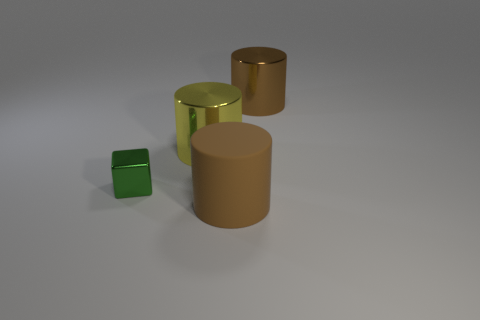What is the shape of the thing that is the same color as the rubber cylinder?
Your response must be concise. Cylinder. Is there a yellow metal thing that is in front of the brown cylinder in front of the green object?
Make the answer very short. No. What number of rubber spheres are the same size as the yellow metal cylinder?
Keep it short and to the point. 0. There is a metal cylinder that is left of the cylinder that is in front of the tiny green metallic cube; what number of big yellow cylinders are behind it?
Offer a very short reply. 0. How many cylinders are in front of the tiny cube and on the left side of the rubber cylinder?
Keep it short and to the point. 0. Is there any other thing that is the same color as the large matte cylinder?
Your answer should be very brief. Yes. How many metallic objects are either tiny cubes or yellow cylinders?
Provide a succinct answer. 2. The big brown object behind the brown cylinder that is to the left of the metal thing on the right side of the yellow object is made of what material?
Your response must be concise. Metal. What material is the brown thing that is left of the large object behind the yellow shiny thing made of?
Offer a terse response. Rubber. There is a cylinder that is in front of the tiny object; is its size the same as the thing that is behind the yellow shiny thing?
Make the answer very short. Yes. 